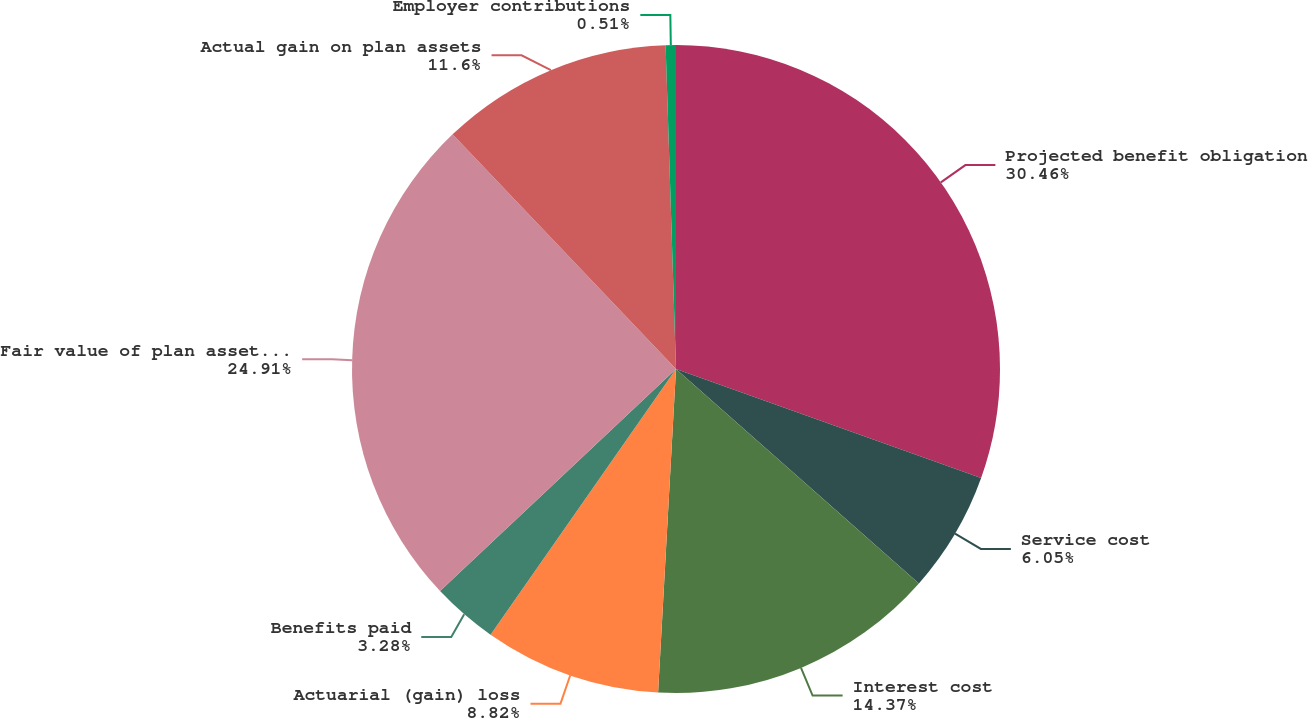Convert chart. <chart><loc_0><loc_0><loc_500><loc_500><pie_chart><fcel>Projected benefit obligation<fcel>Service cost<fcel>Interest cost<fcel>Actuarial (gain) loss<fcel>Benefits paid<fcel>Fair value of plan assets at<fcel>Actual gain on plan assets<fcel>Employer contributions<nl><fcel>30.46%<fcel>6.05%<fcel>14.37%<fcel>8.82%<fcel>3.28%<fcel>24.91%<fcel>11.6%<fcel>0.51%<nl></chart> 